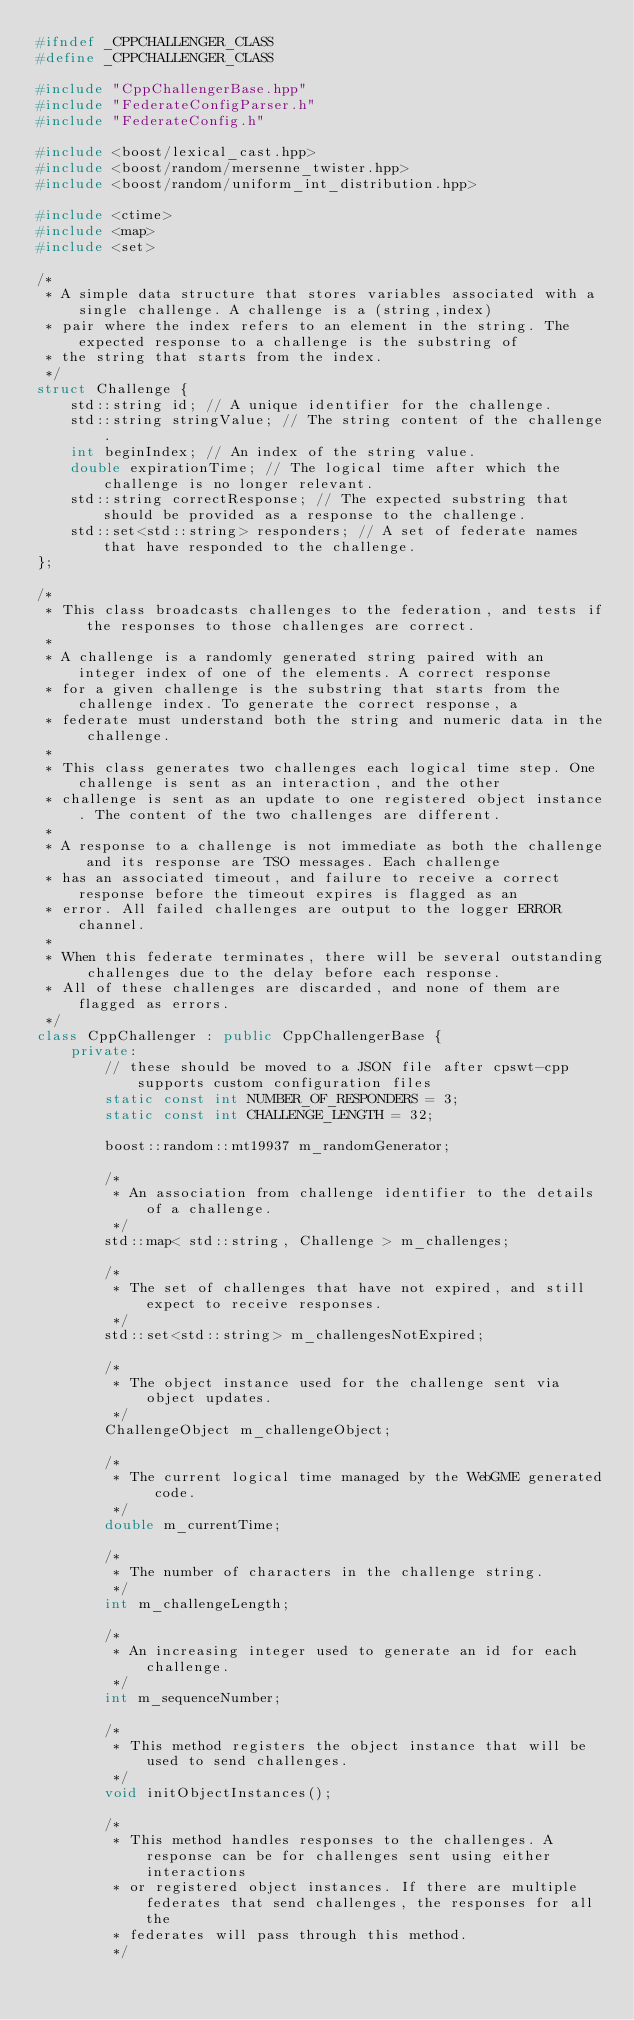<code> <loc_0><loc_0><loc_500><loc_500><_C++_>#ifndef _CPPCHALLENGER_CLASS
#define _CPPCHALLENGER_CLASS

#include "CppChallengerBase.hpp"
#include "FederateConfigParser.h"
#include "FederateConfig.h"

#include <boost/lexical_cast.hpp>
#include <boost/random/mersenne_twister.hpp>
#include <boost/random/uniform_int_distribution.hpp>

#include <ctime>
#include <map>
#include <set>

/*
 * A simple data structure that stores variables associated with a single challenge. A challenge is a (string,index)
 * pair where the index refers to an element in the string. The expected response to a challenge is the substring of
 * the string that starts from the index.
 */
struct Challenge {
    std::string id; // A unique identifier for the challenge.
    std::string stringValue; // The string content of the challenge.
    int beginIndex; // An index of the string value.
    double expirationTime; // The logical time after which the challenge is no longer relevant.
    std::string correctResponse; // The expected substring that should be provided as a response to the challenge.
    std::set<std::string> responders; // A set of federate names that have responded to the challenge.
};

/*
 * This class broadcasts challenges to the federation, and tests if the responses to those challenges are correct.
 *
 * A challenge is a randomly generated string paired with an integer index of one of the elements. A correct response
 * for a given challenge is the substring that starts from the challenge index. To generate the correct response, a
 * federate must understand both the string and numeric data in the challenge.
 *
 * This class generates two challenges each logical time step. One challenge is sent as an interaction, and the other
 * challenge is sent as an update to one registered object instance. The content of the two challenges are different.
 *
 * A response to a challenge is not immediate as both the challenge and its response are TSO messages. Each challenge
 * has an associated timeout, and failure to receive a correct response before the timeout expires is flagged as an
 * error. All failed challenges are output to the logger ERROR channel.
 *
 * When this federate terminates, there will be several outstanding challenges due to the delay before each response.
 * All of these challenges are discarded, and none of them are flagged as errors.
 */
class CppChallenger : public CppChallengerBase {
    private:
        // these should be moved to a JSON file after cpswt-cpp supports custom configuration files
        static const int NUMBER_OF_RESPONDERS = 3;
        static const int CHALLENGE_LENGTH = 32;

        boost::random::mt19937 m_randomGenerator;

        /*
         * An association from challenge identifier to the details of a challenge.
         */
        std::map< std::string, Challenge > m_challenges;

        /*
         * The set of challenges that have not expired, and still expect to receive responses.
         */
        std::set<std::string> m_challengesNotExpired;

        /*
         * The object instance used for the challenge sent via object updates.
         */
        ChallengeObject m_challengeObject;

        /*
         * The current logical time managed by the WebGME generated code.
         */
        double m_currentTime;

        /*
         * The number of characters in the challenge string.
         */
        int m_challengeLength;

        /*
         * An increasing integer used to generate an id for each challenge.
         */
        int m_sequenceNumber;

        /*
         * This method registers the object instance that will be used to send challenges.
         */
        void initObjectInstances();

        /*
         * This method handles responses to the challenges. A response can be for challenges sent using either interactions
         * or registered object instances. If there are multiple federates that send challenges, the responses for all the
         * federates will pass through this method.
         */</code> 